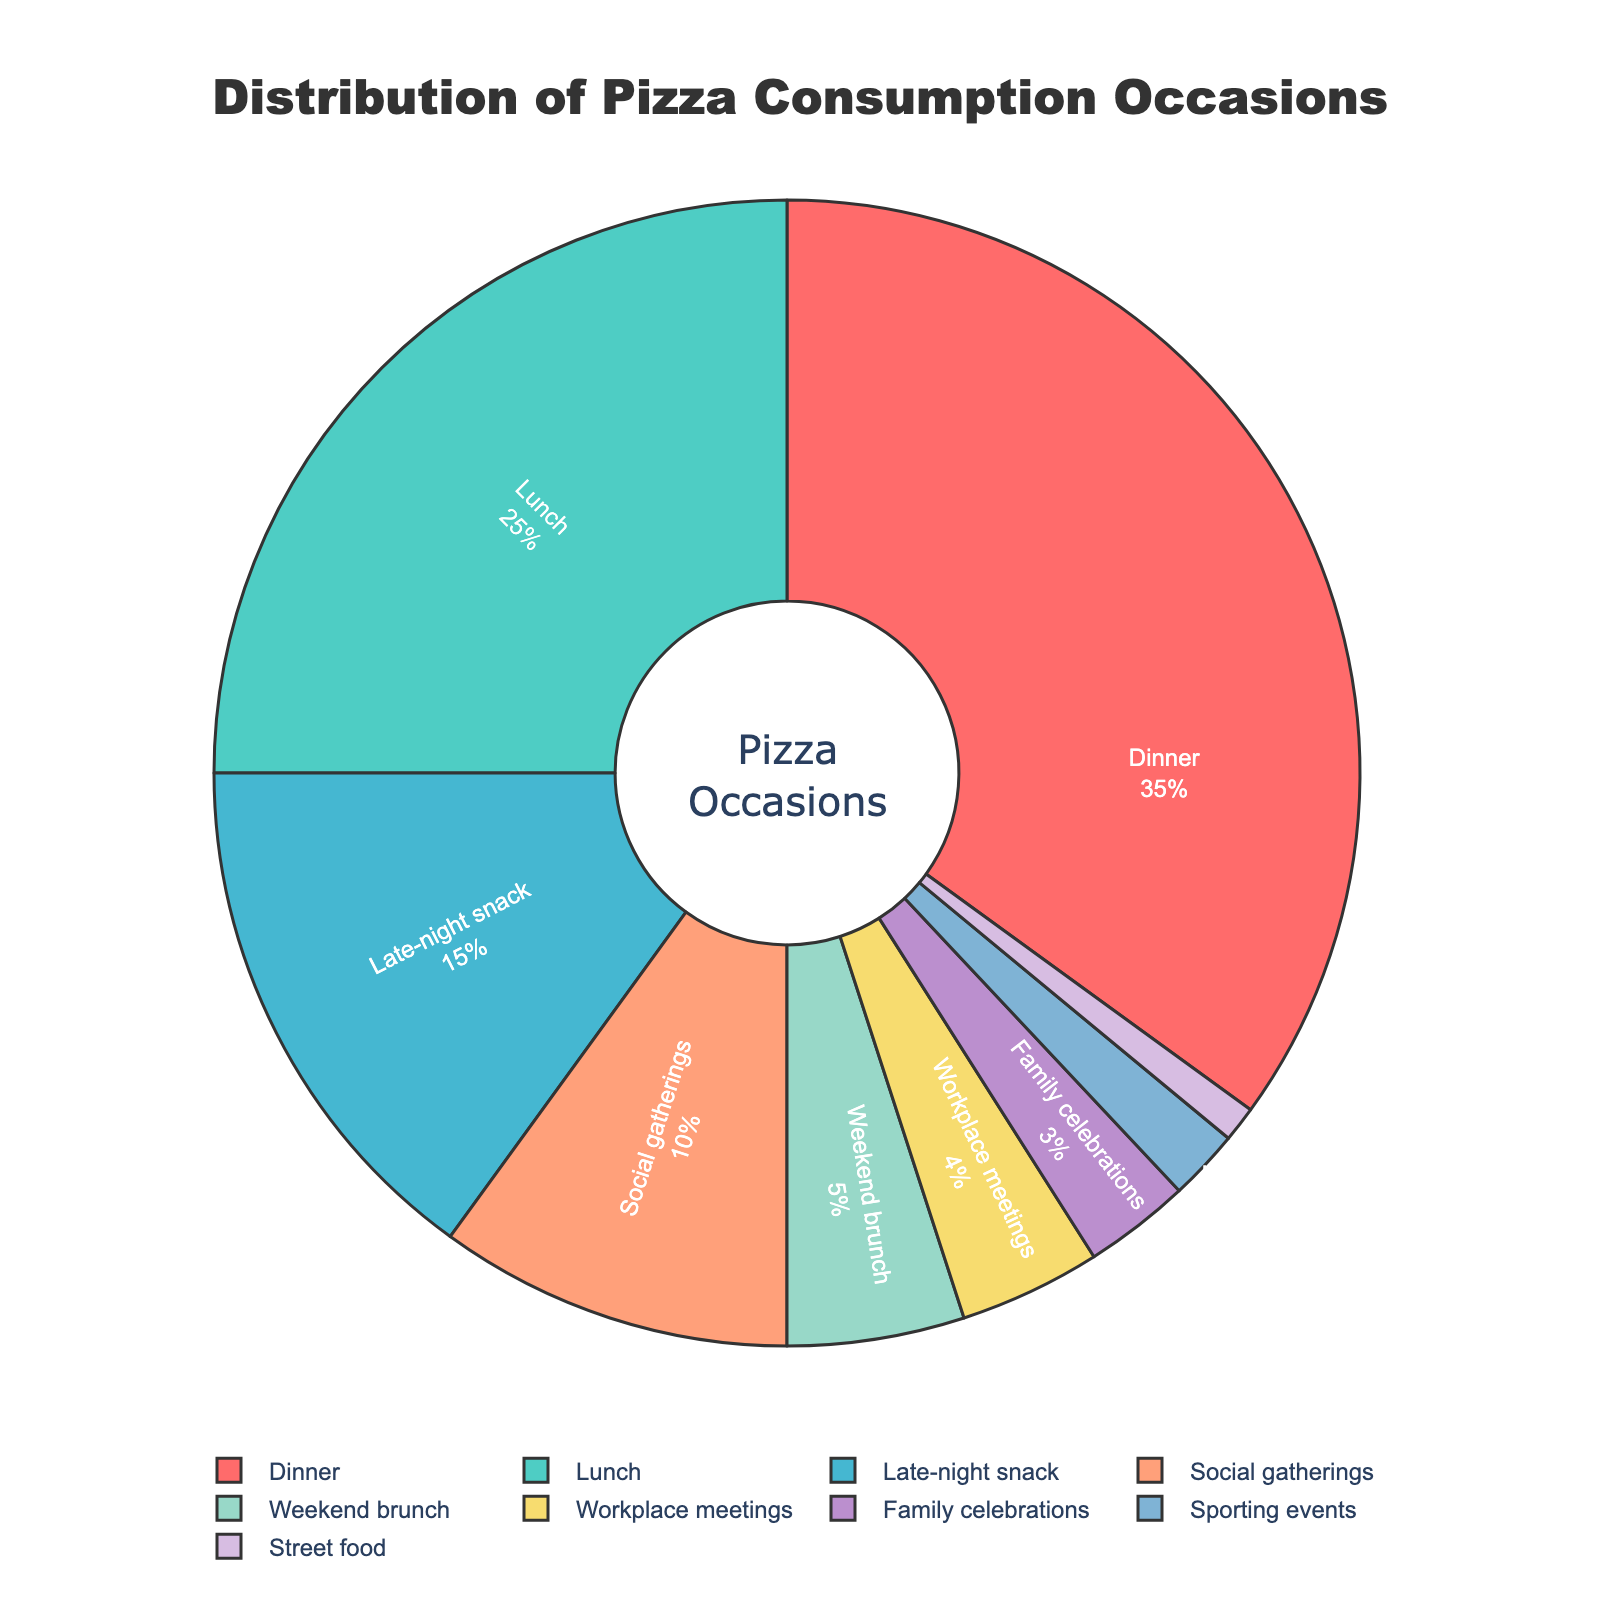Which occasion has the highest pizza consumption percentage? Observing the chart, the section labeled "Dinner" is the largest segment of the pie. This directly indicates that dinner has the highest pizza consumption percentage at 35%
Answer: Dinner Which occasion has a greater percentage, lunch or late-night snack? Comparing the sizes of the segments for lunch and late-night snack, lunch is larger. Lunch has a percentage of 25% while late-night snack has 15%, making lunch greater.
Answer: Lunch What is the combined percentage for social gatherings and workplace meetings? The percentage values for social gatherings and workplace meetings are 10% and 4%, respectively. Adding these together, 10 + 4 = 14%.
Answer: 14% How much more significant is pizza consumption at dinner compared to family celebrations? Dinner accounts for 35% whereas family celebrations account for 3%. The difference in their percentages is calculated by subtracting 3 from 35, giving 35 - 3 = 32%.
Answer: 32% If you add the percentages of weekend brunch and street food, what do you get? The chart lists weekend brunch at 5% and street food at 1%. Adding these together, 5 + 1 = 6%.
Answer: 6% Is pizza consumption at sporting events higher, lower, or equal to family celebrations? The pie chart shows the sporting events section to be smaller than family celebrations. Sporting events have a consumption percentage of 2%, while family celebrations have 3%. Therefore, it is lower.
Answer: Lower What color represents social gatherings on the pie chart? The color representing social gatherings on the pie chart is orange, as evidenced by observing the segment labeled "Social gatherings."
Answer: Orange How does the percentage of lunch compare to the sum of weekend brunch and workplace meetings? Lunch has a consumption percentage of 25%. Weekend brunch (5%) and workplace meetings (4%) together sum up to 5 + 4 = 9%. Comparing the numbers, 25% (lunch) is greater than 9%.
Answer: Greater Which occasion has the lowest percentage, and what is its value? Analyzing the pie chart, the smallest segment is labeled "Street food" with a consumption percentage of 1%.
Answer: Street food If family celebrations and street food percentages were combined, would they exceed social gatherings? Family celebrations have 3% and street food has 1%. Combined, they sum up to 3 + 1 = 4%. Social gatherings have a percentage of 10%, which is higher than 4%. So, the combined percentage does not exceed social gatherings.
Answer: No 